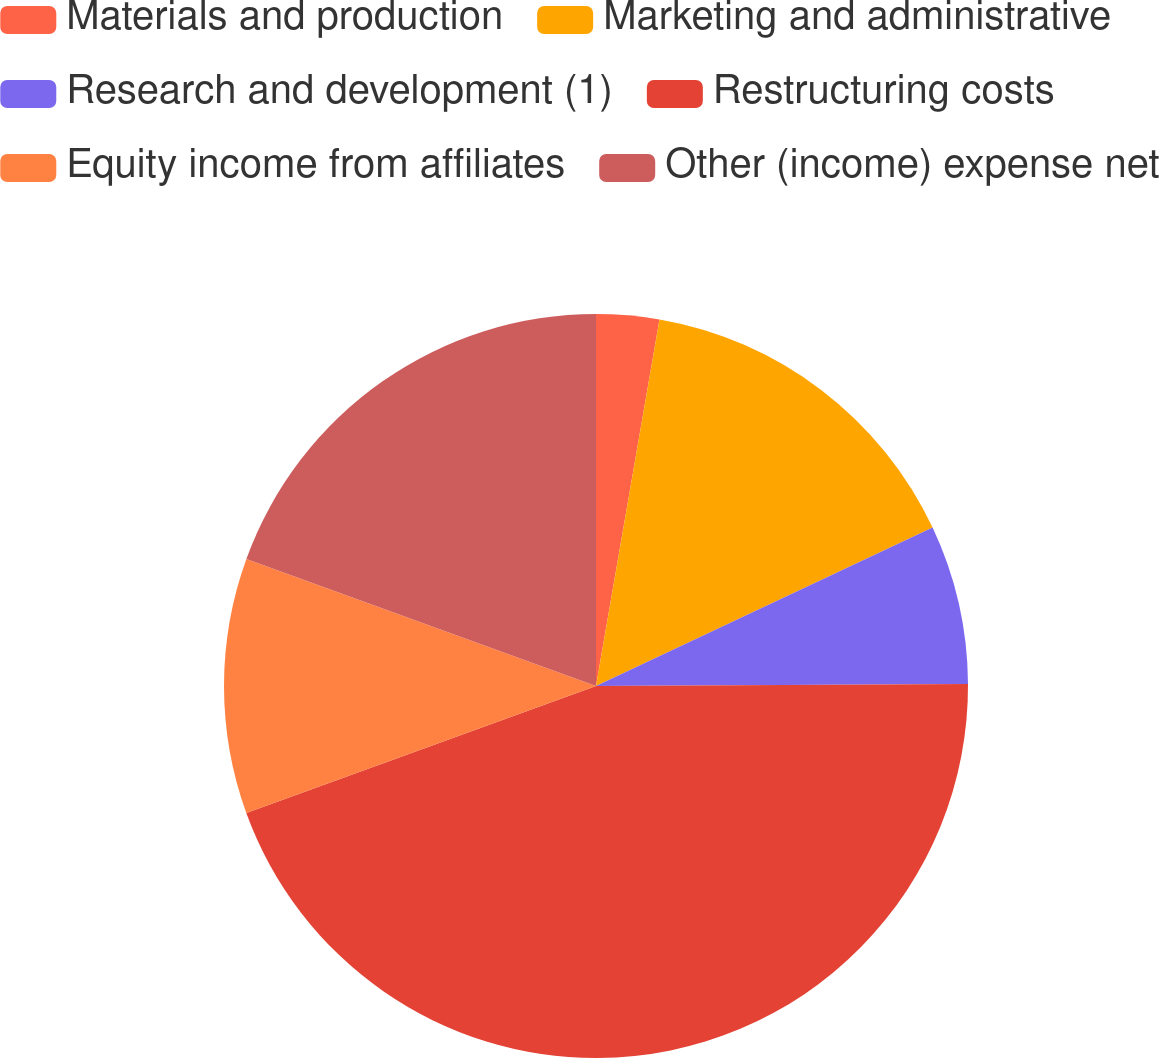<chart> <loc_0><loc_0><loc_500><loc_500><pie_chart><fcel>Materials and production<fcel>Marketing and administrative<fcel>Research and development (1)<fcel>Restructuring costs<fcel>Equity income from affiliates<fcel>Other (income) expense net<nl><fcel>2.73%<fcel>15.27%<fcel>6.91%<fcel>44.55%<fcel>11.09%<fcel>19.45%<nl></chart> 